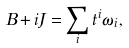Convert formula to latex. <formula><loc_0><loc_0><loc_500><loc_500>B + i J = \sum _ { i } t ^ { i } \omega _ { i } ,</formula> 